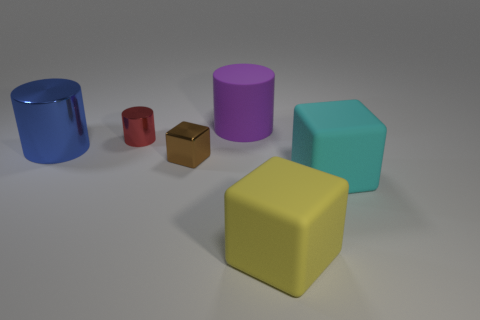Subtract all large cylinders. How many cylinders are left? 1 Subtract 1 cylinders. How many cylinders are left? 2 Add 3 purple rubber objects. How many objects exist? 9 Add 3 purple cylinders. How many purple cylinders are left? 4 Add 2 big blue shiny things. How many big blue shiny things exist? 3 Subtract 0 cyan spheres. How many objects are left? 6 Subtract all small blue rubber balls. Subtract all cubes. How many objects are left? 3 